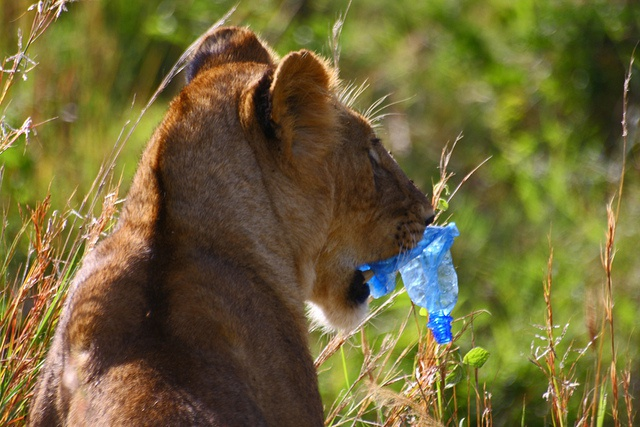Describe the objects in this image and their specific colors. I can see a bottle in olive, lightblue, and blue tones in this image. 